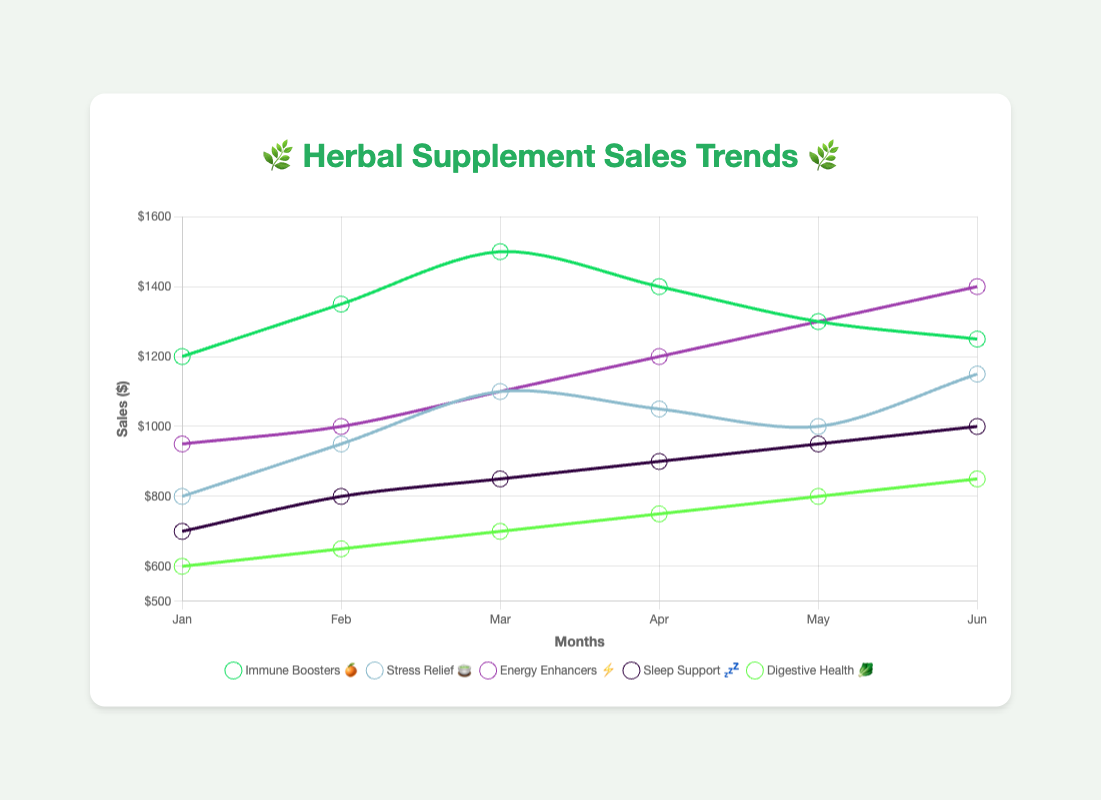What's the title of the chart? The title of the chart is typically displayed at the top of the figure. Here, it is clearly marked.
Answer: 🌿 Herbal Supplement Sales Trends 🌿 Which category had the highest sales in March? To find this, look at the sales numbers for each category in March. Immune Boosters: 1500; Stress Relief: 1100; Energy Enhancers: 1100; Sleep Support: 850; Digestive Health: 700. The highest is Immune Boosters at 1500.
Answer: Immune Boosters 🍊 How did the sales of Energy Enhancers ⚡ change from January to June? Check the sales figures for Energy Enhancers in January and June. January: 950, June: 1400. Calculate the difference: 1400 - 950 = 450. So, sales increased by 450 units.
Answer: Increased by 450 Which month saw the highest combined sales for all categories? Sum up the sales for each month and compare: 
Jan: 1200+800+950+700+600=4250, 
Feb: 1350+950+1000+800+650=4750, 
Mar: 1500+1100+1100+850+700=5250, 
Apr: 1400+1050+1200+900+750=5300,  
May: 1300+1000+1300+950+800=5350, 
Jun: 1250+1150+1400+1000+850=5650. The highest total is in June.
Answer: June Which category showed the most consistent sales trend over the months? Look at the sales trend lines for each category. The one with the smallest variation is likely the most consistent. Digestive Health has the smallest range: Jan: 600, Jun: 850 (a difference of 250).
Answer: Digestive Health 🥬 Which category has the highest average sales over the six months? Calculate the average sales for each category:
Immune Boosters: (1200+1350+1500+1400+1300+1250) / 6 = 1333.33,
Stress Relief: (800+950+1100+1050+1000+1150) / 6 = 1008.33, 
Energy Enhancers: (950+1000+1100+1200+1300+1400) / 6 = 1158.33, 
Sleep Support: (700+800+850+900+950+1000) / 6 = 866.67, 
Digestive Health: (600+650+700+750+800+850) / 6 = 725. Immune Boosters has the highest average sales.
Answer: Immune Boosters 🍊 What is the increase in sales for Sleep Support 💤 from January to June? Look at the sales numbers for Sleep Support in January and June. January: 700, June: 1000. Calculate the difference: 1000 - 700 = 300.
Answer: 300 Between Stress Relief 🍵 and Energy Enhancers ⚡, which category had a larger percentage increase in sales from January to June? Calculate the percentage increase for each:
Stress Relief: (1150-800)/800 * 100 = 43.75%,
Energy Enhancers: (1400-950)/950 * 100 = 47.37%. Energy Enhancers had a larger percentage increase.
Answer: Energy Enhancers ⚡ In which month did Immune Boosters 🍊 peak in sales? Look for the highest sales number for Immune Boosters in the dataset. The peak month is March with 1500 sales.
Answer: March 